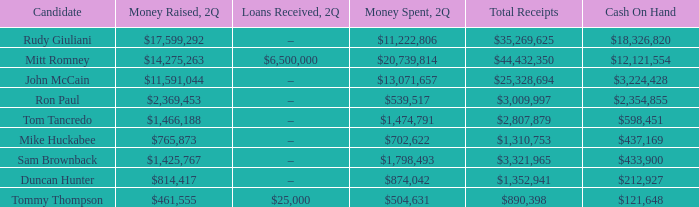What is the amount of money collected when 2q has total earnings of $890,398? $461,555. Parse the table in full. {'header': ['Candidate', 'Money Raised, 2Q', 'Loans Received, 2Q', 'Money Spent, 2Q', 'Total Receipts', 'Cash On Hand'], 'rows': [['Rudy Giuliani', '$17,599,292', '–', '$11,222,806', '$35,269,625', '$18,326,820'], ['Mitt Romney', '$14,275,263', '$6,500,000', '$20,739,814', '$44,432,350', '$12,121,554'], ['John McCain', '$11,591,044', '–', '$13,071,657', '$25,328,694', '$3,224,428'], ['Ron Paul', '$2,369,453', '–', '$539,517', '$3,009,997', '$2,354,855'], ['Tom Tancredo', '$1,466,188', '–', '$1,474,791', '$2,807,879', '$598,451'], ['Mike Huckabee', '$765,873', '–', '$702,622', '$1,310,753', '$437,169'], ['Sam Brownback', '$1,425,767', '–', '$1,798,493', '$3,321,965', '$433,900'], ['Duncan Hunter', '$814,417', '–', '$874,042', '$1,352,941', '$212,927'], ['Tommy Thompson', '$461,555', '$25,000', '$504,631', '$890,398', '$121,648']]} 